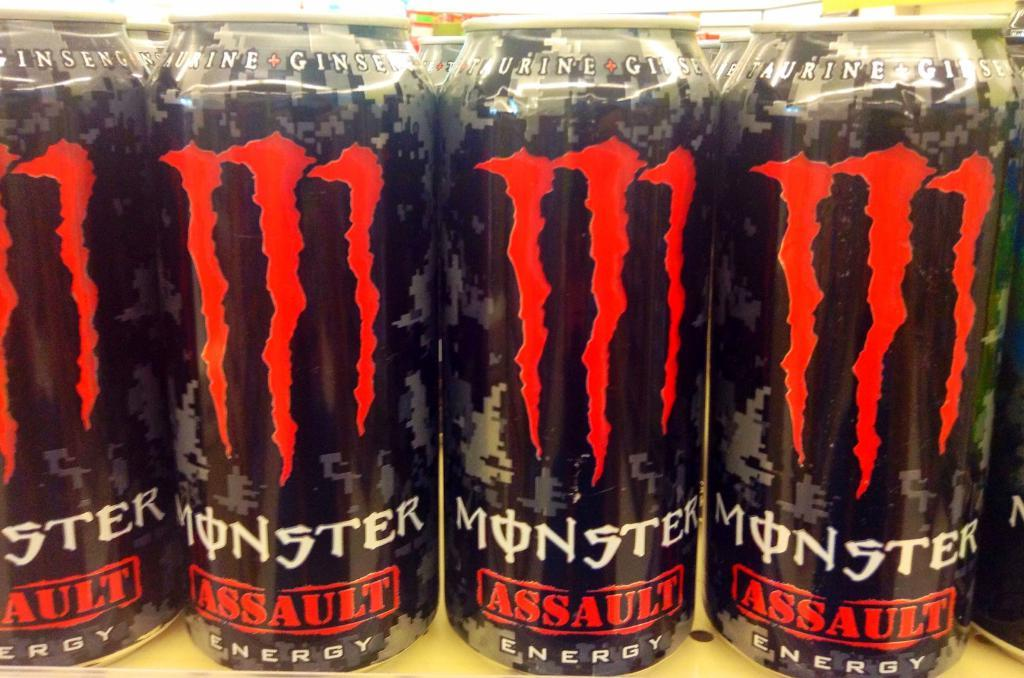<image>
Share a concise interpretation of the image provided. A grouping of cans for Monster assault energy drinks. 